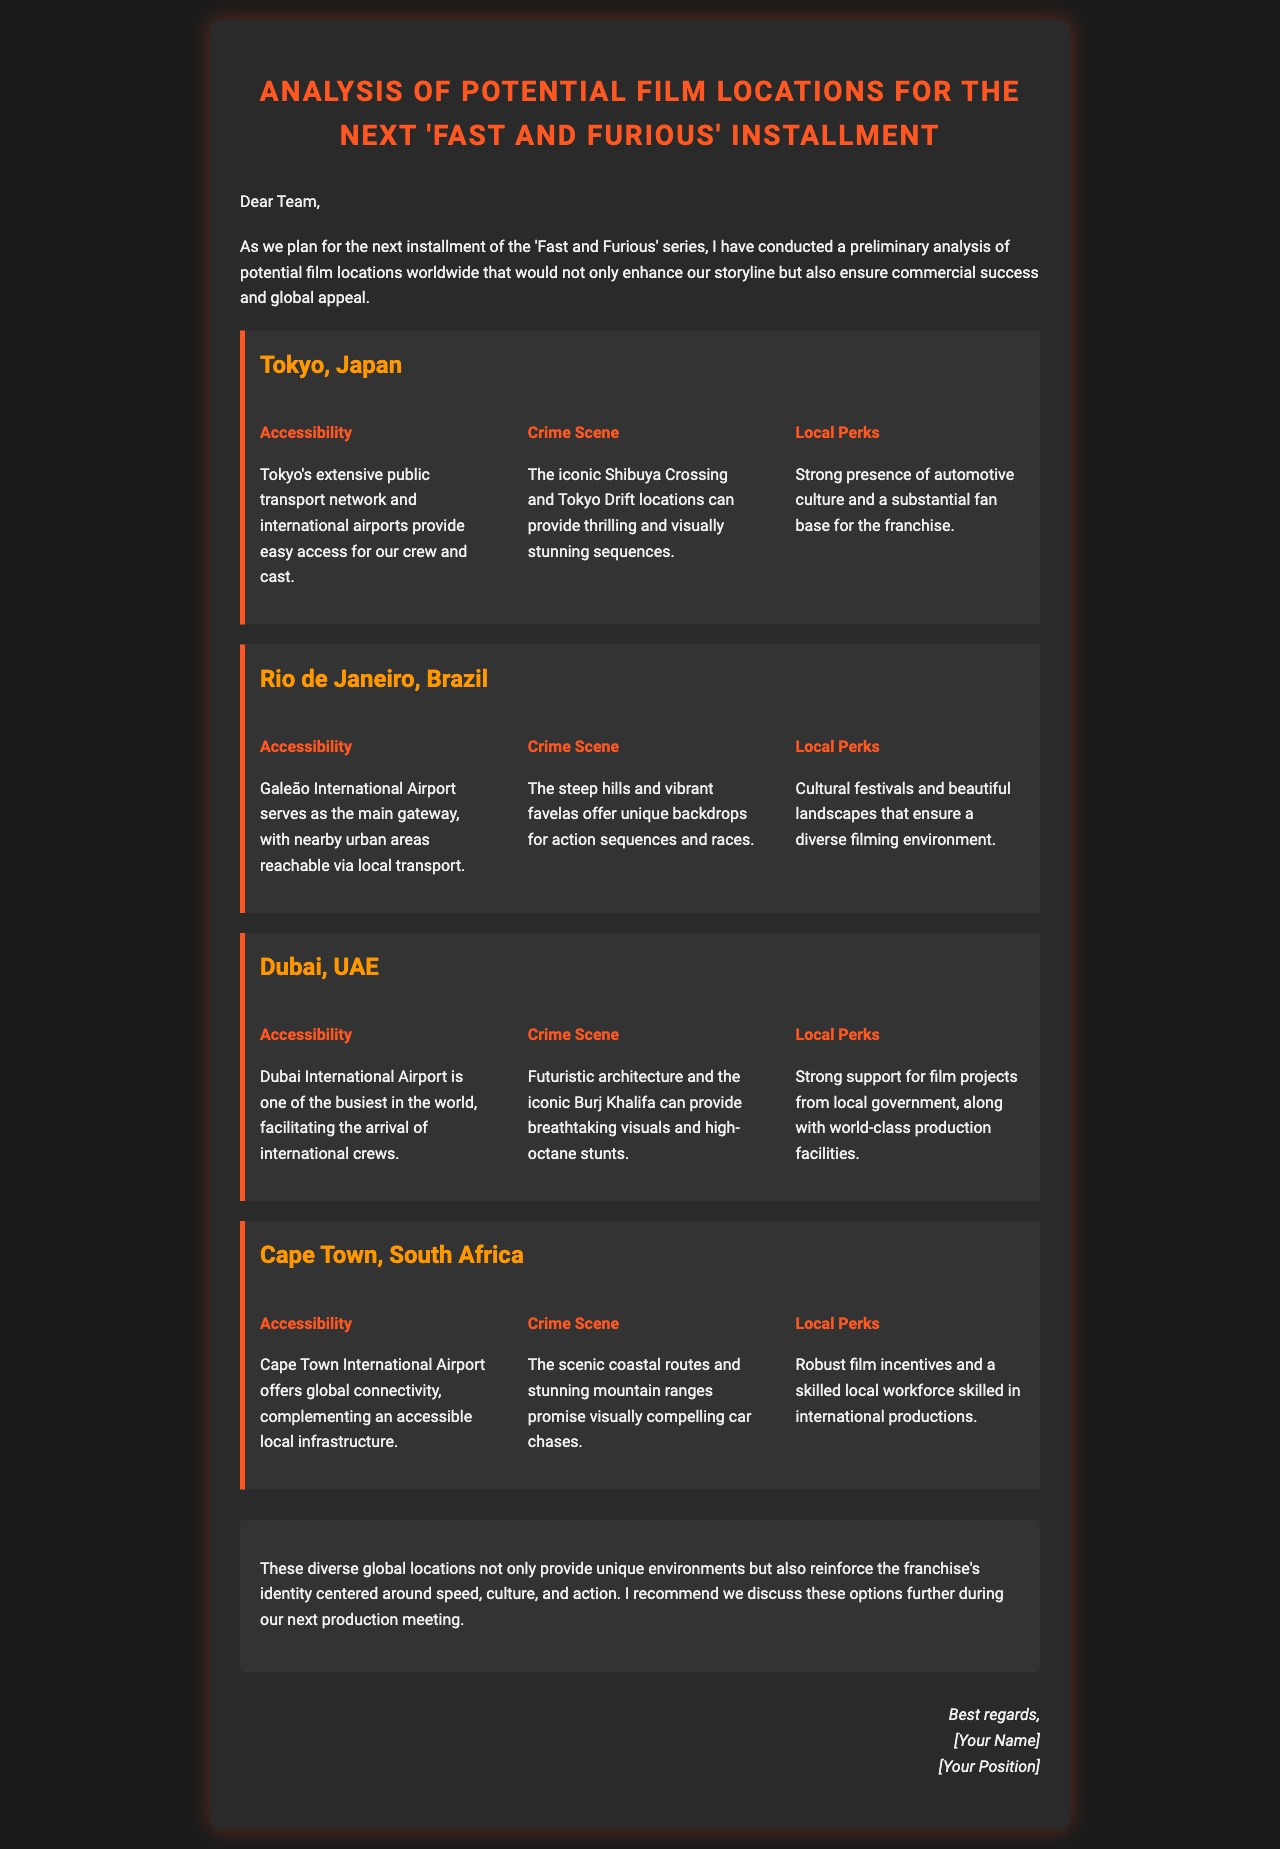What is the main focus of the email? The email discusses the analysis of potential film locations for the next installment of the 'Fast and Furious' series.
Answer: analysis of potential film locations How many locations are analyzed in the document? The document lists four potential film locations.
Answer: four What is the local perk mentioned for Tokyo? The local perk for Tokyo is the strong presence of automotive culture and a substantial fan base for the franchise.
Answer: strong presence of automotive culture Which location offers breathtaking visuals from an iconic building? The location with breathtaking visuals from an iconic building is Dubai.
Answer: Dubai What does Cape Town's local workforce offer for filming? Cape Town's local workforce offers skills in international productions.
Answer: skilled local workforce What is highlighted about Rio de Janeiro's landscape? The highlight is that the steep hills and vibrant favelas offer unique backdrops for action sequences and races.
Answer: steep hills and vibrant favelas What type of environment do the locations provide? The locations provide diverse global environments.
Answer: diverse global environments What will be discussed in the next production meeting? The next production meeting will discuss the potential film locations further.
Answer: potential film locations 